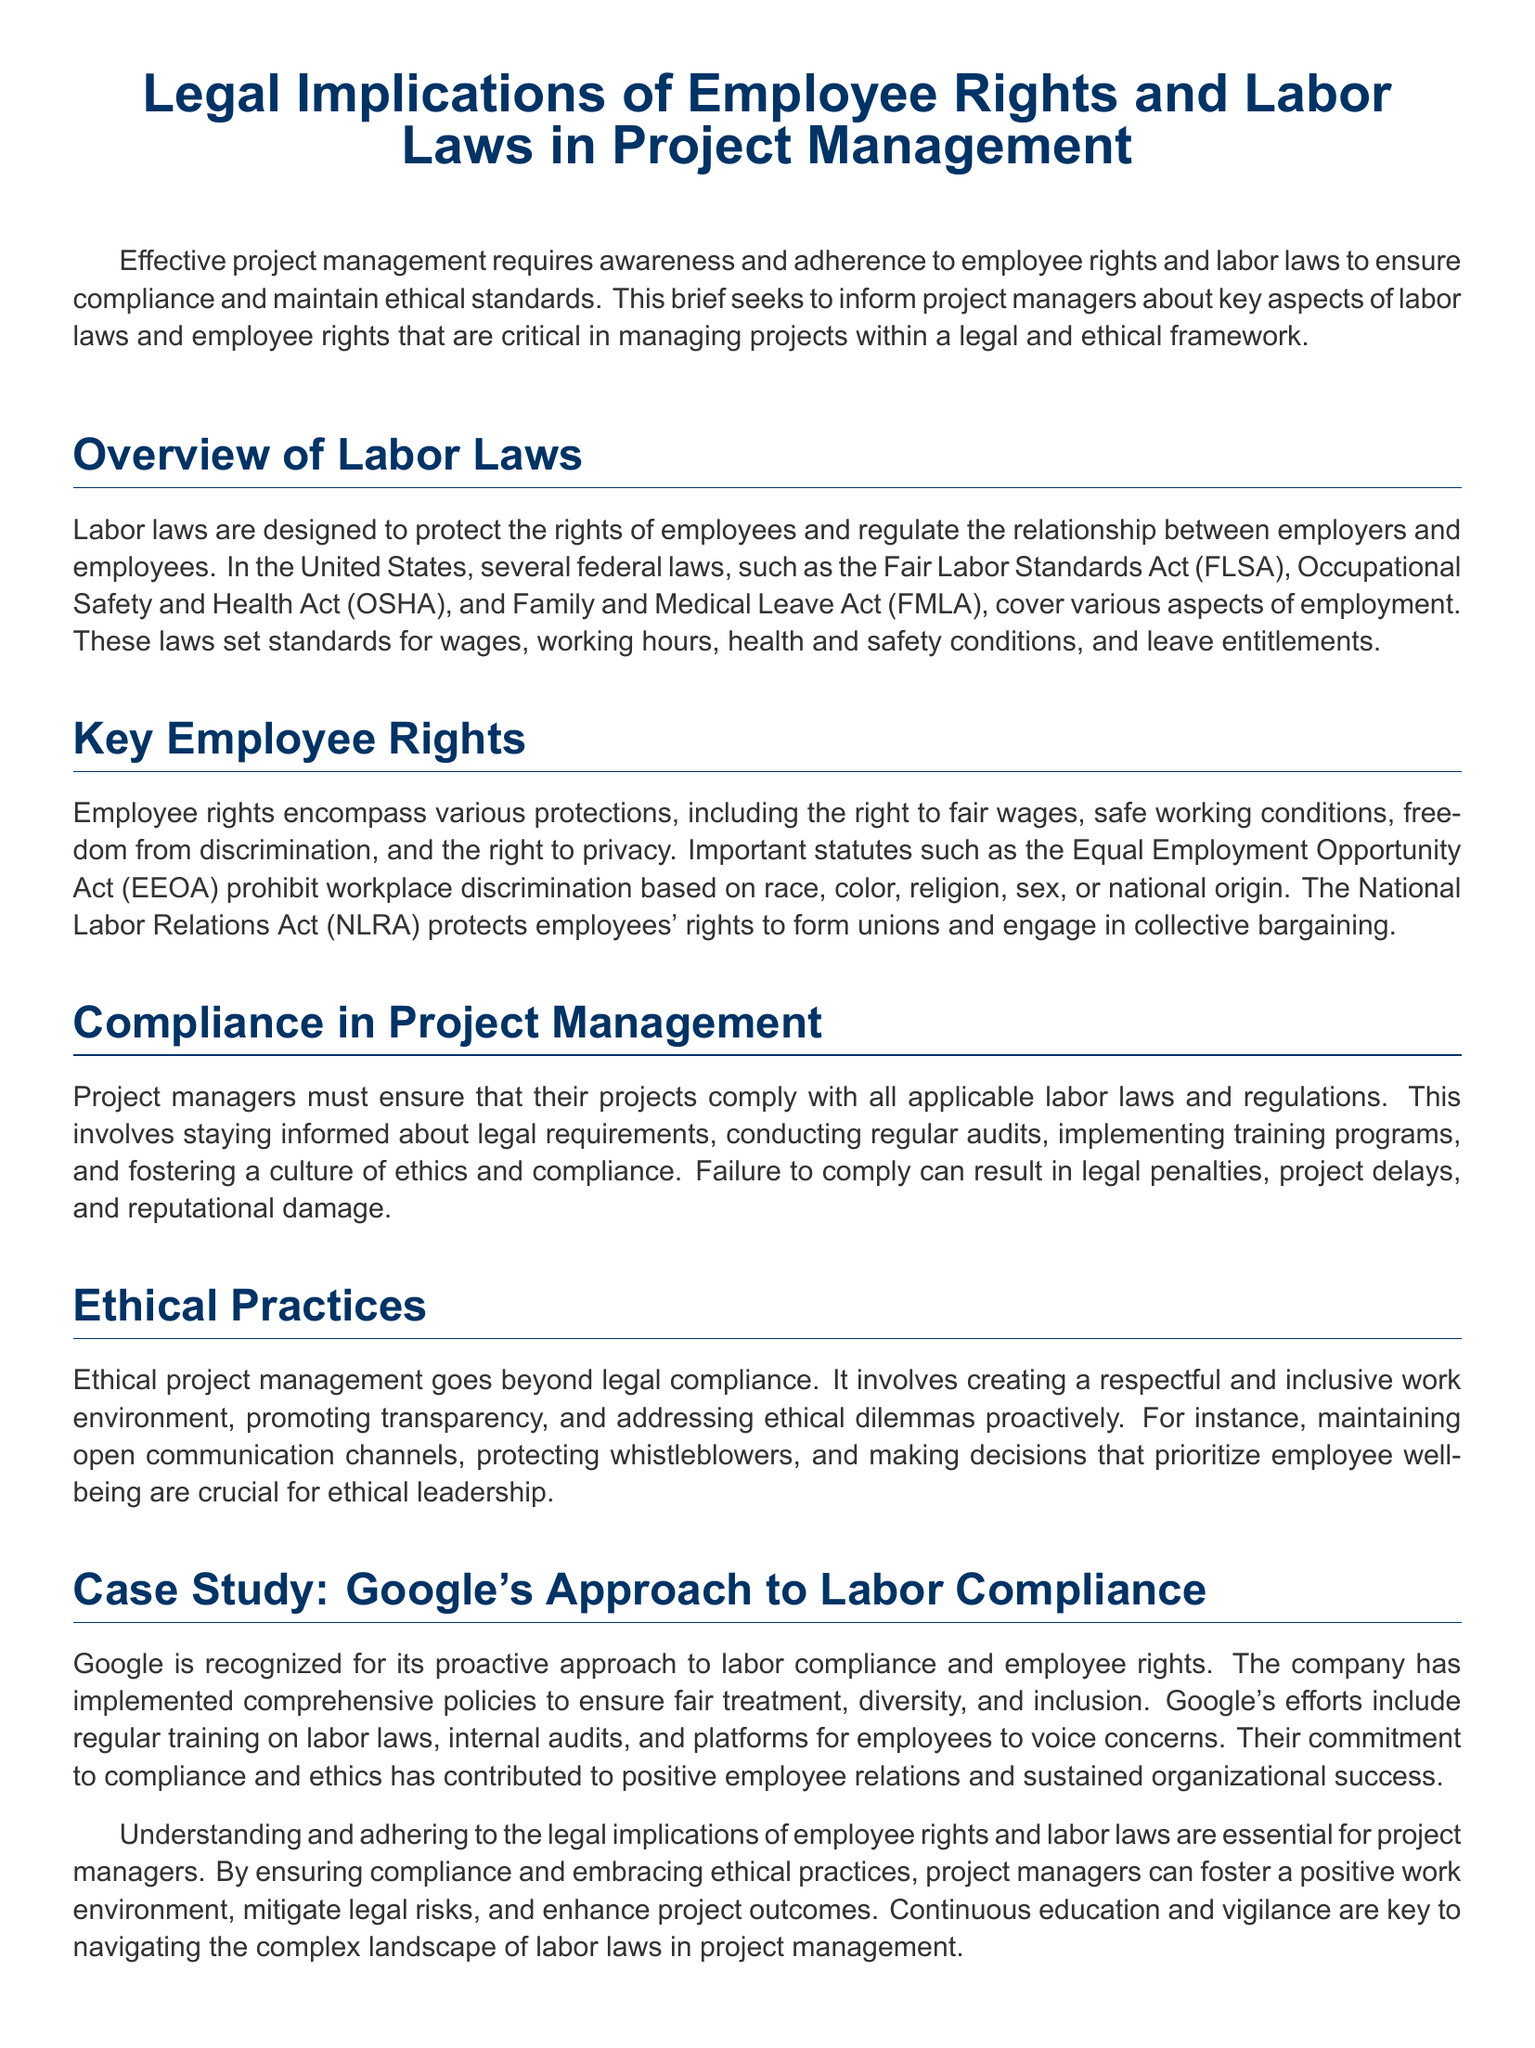What is the focus of the legal brief? The focus of the legal brief is to inform project managers about key aspects of labor laws and employee rights that are critical in managing projects within a legal and ethical framework.
Answer: key aspects of labor laws and employee rights Which law addresses workplace discrimination? The Equal Employment Opportunity Act (EEOA) addresses workplace discrimination based on race, color, religion, sex, or national origin.
Answer: Equal Employment Opportunity Act (EEOA) What does OSHA stand for? OSHA stands for the Occupational Safety and Health Act, which is a federal law that regulates health and safety conditions in the workplace.
Answer: Occupational Safety and Health Act What is one consequence of failing to comply with labor laws? A consequence of failing to comply with labor laws can be legal penalties.
Answer: legal penalties How does ethical project management go beyond legal compliance? Ethical project management involves creating a respectful and inclusive work environment, promoting transparency, and addressing ethical dilemmas proactively.
Answer: creating a respectful and inclusive work environment What company is recognized for its proactive approach to labor compliance? Google is recognized for its proactive approach to labor compliance and employee rights.
Answer: Google What is one approach Google uses to ensure labor compliance? Google conducts regular training on labor laws as part of its approach to ensure labor compliance.
Answer: regular training on labor laws What is essential for project managers to navigate labor laws? Continuous education and vigilance are essential for project managers to navigate the complex landscape of labor laws in project management.
Answer: Continuous education and vigilance 